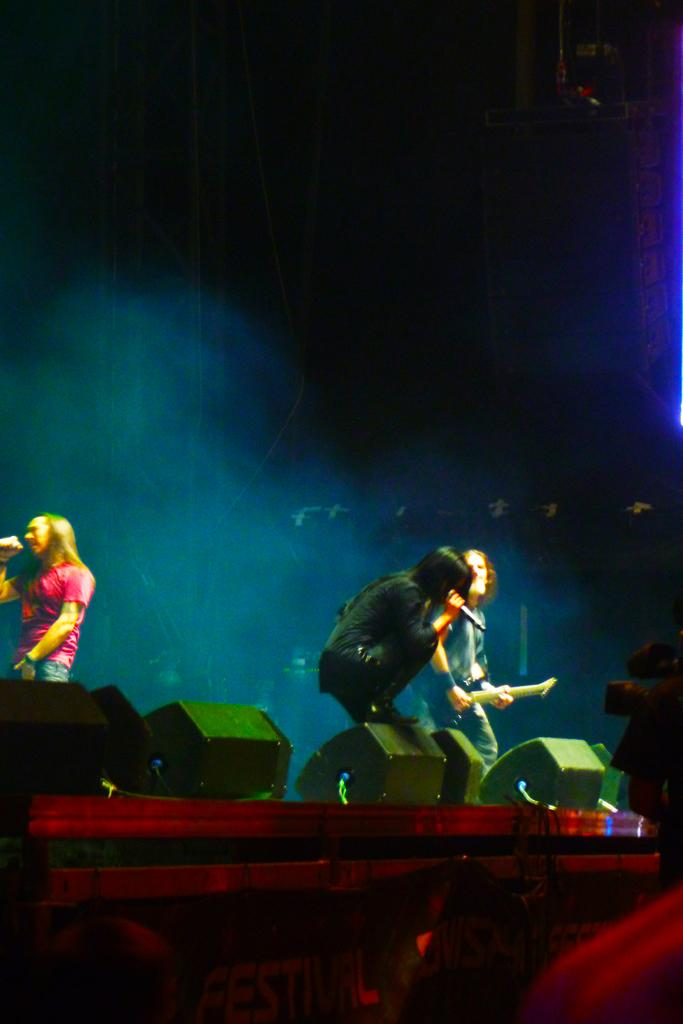What are the people in the image holding? The people in the image are holding mics. What else can be seen in the image besides the people holding mics? There are speakers in the image. Where are the people located in the image? The people are at the bottom of the image. What can be seen in the background of the image? There are rods in the background of the image. What type of knot is used to secure the rods in the background of the image? There is no knot visible in the image, as the rods are not tied together. 